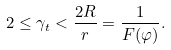<formula> <loc_0><loc_0><loc_500><loc_500>2 \leq \gamma _ { t } < \frac { 2 R } { r } = \frac { 1 } { F ( \varphi ) } .</formula> 